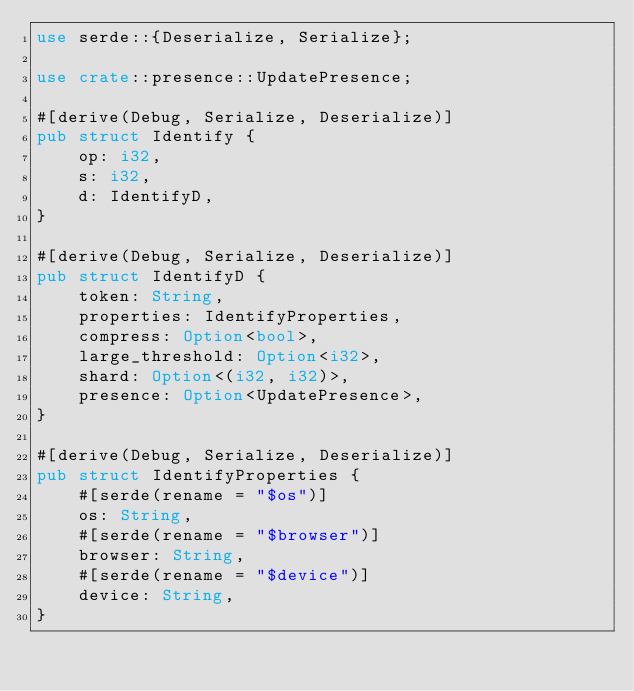<code> <loc_0><loc_0><loc_500><loc_500><_Rust_>use serde::{Deserialize, Serialize};

use crate::presence::UpdatePresence;

#[derive(Debug, Serialize, Deserialize)]
pub struct Identify {
    op: i32,
    s: i32,
    d: IdentifyD,
}

#[derive(Debug, Serialize, Deserialize)]
pub struct IdentifyD {
    token: String,
    properties: IdentifyProperties,
    compress: Option<bool>,
    large_threshold: Option<i32>,
    shard: Option<(i32, i32)>,
    presence: Option<UpdatePresence>,
}

#[derive(Debug, Serialize, Deserialize)]
pub struct IdentifyProperties {
    #[serde(rename = "$os")]
    os: String,
    #[serde(rename = "$browser")]
    browser: String,
    #[serde(rename = "$device")]
    device: String,
}
</code> 